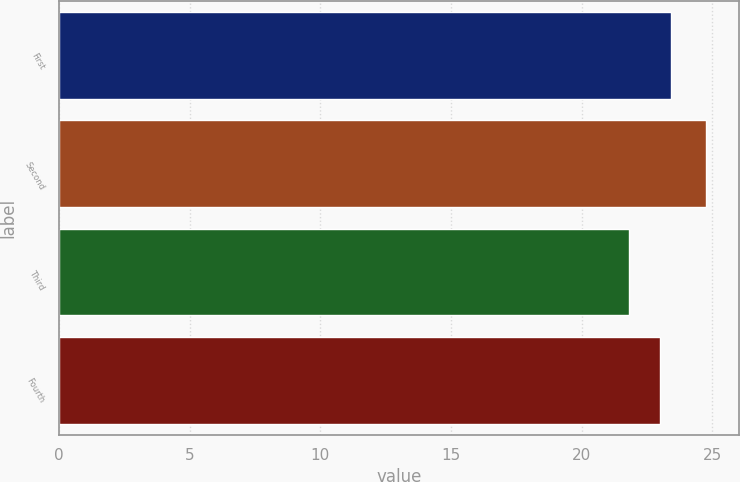Convert chart. <chart><loc_0><loc_0><loc_500><loc_500><bar_chart><fcel>First<fcel>Second<fcel>Third<fcel>Fourth<nl><fcel>23.44<fcel>24.78<fcel>21.8<fcel>22.99<nl></chart> 